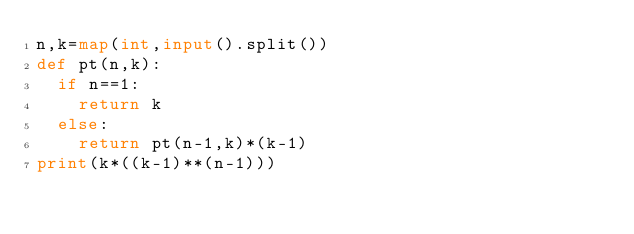Convert code to text. <code><loc_0><loc_0><loc_500><loc_500><_Python_>n,k=map(int,input().split())
def pt(n,k):
  if n==1:
    return k
  else:
    return pt(n-1,k)*(k-1)
print(k*((k-1)**(n-1)))
</code> 